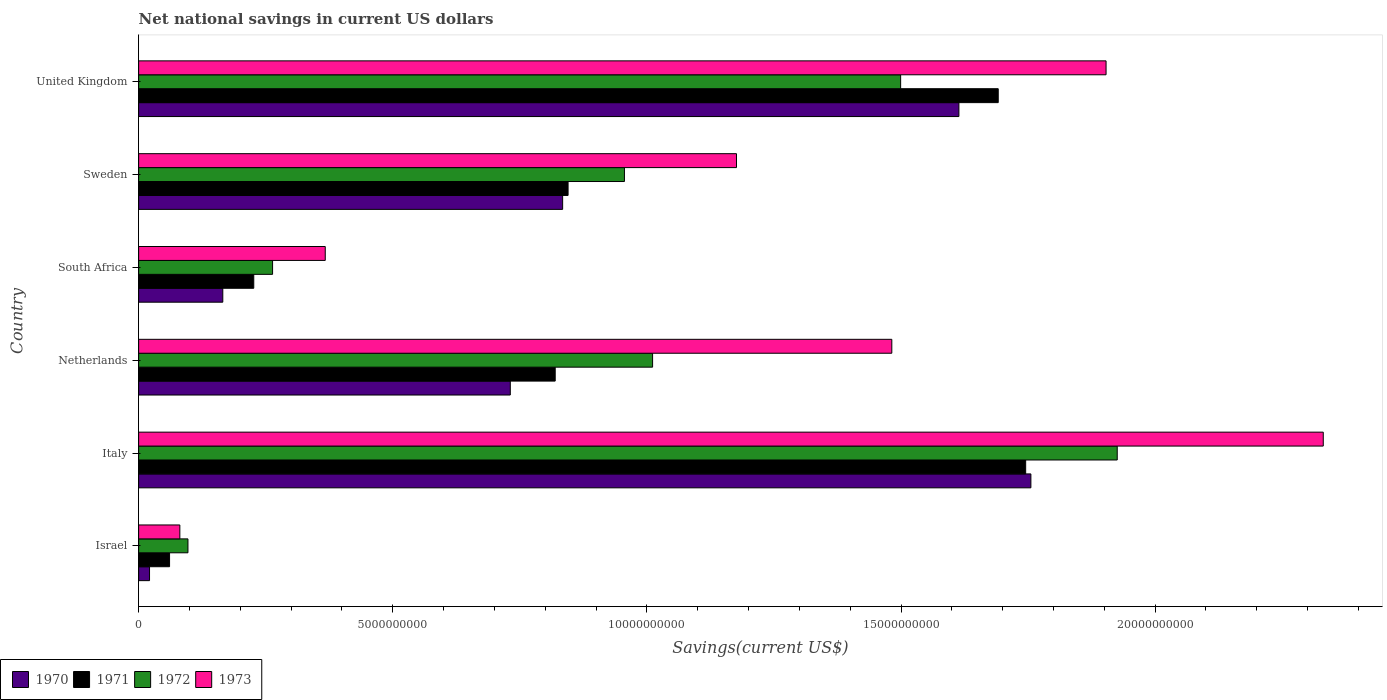How many different coloured bars are there?
Your response must be concise. 4. How many groups of bars are there?
Provide a succinct answer. 6. Are the number of bars per tick equal to the number of legend labels?
Ensure brevity in your answer.  Yes. Are the number of bars on each tick of the Y-axis equal?
Offer a very short reply. Yes. How many bars are there on the 5th tick from the top?
Offer a terse response. 4. How many bars are there on the 3rd tick from the bottom?
Ensure brevity in your answer.  4. What is the net national savings in 1971 in Israel?
Provide a succinct answer. 6.09e+08. Across all countries, what is the maximum net national savings in 1971?
Your response must be concise. 1.75e+1. Across all countries, what is the minimum net national savings in 1973?
Make the answer very short. 8.11e+08. What is the total net national savings in 1973 in the graph?
Provide a succinct answer. 7.34e+1. What is the difference between the net national savings in 1971 in Italy and that in Netherlands?
Your answer should be compact. 9.26e+09. What is the difference between the net national savings in 1973 in United Kingdom and the net national savings in 1970 in South Africa?
Your response must be concise. 1.74e+1. What is the average net national savings in 1973 per country?
Provide a short and direct response. 1.22e+1. What is the difference between the net national savings in 1971 and net national savings in 1972 in Sweden?
Your response must be concise. -1.11e+09. What is the ratio of the net national savings in 1970 in Italy to that in South Africa?
Your answer should be compact. 10.6. What is the difference between the highest and the second highest net national savings in 1973?
Ensure brevity in your answer.  4.27e+09. What is the difference between the highest and the lowest net national savings in 1970?
Keep it short and to the point. 1.73e+1. In how many countries, is the net national savings in 1973 greater than the average net national savings in 1973 taken over all countries?
Your answer should be compact. 3. Is the sum of the net national savings in 1973 in Netherlands and United Kingdom greater than the maximum net national savings in 1970 across all countries?
Provide a short and direct response. Yes. Is it the case that in every country, the sum of the net national savings in 1973 and net national savings in 1972 is greater than the sum of net national savings in 1971 and net national savings in 1970?
Provide a short and direct response. No. What does the 3rd bar from the bottom in Italy represents?
Offer a terse response. 1972. Is it the case that in every country, the sum of the net national savings in 1972 and net national savings in 1971 is greater than the net national savings in 1970?
Ensure brevity in your answer.  Yes. How many bars are there?
Your answer should be compact. 24. Are the values on the major ticks of X-axis written in scientific E-notation?
Make the answer very short. No. Does the graph contain grids?
Your answer should be compact. No. How many legend labels are there?
Ensure brevity in your answer.  4. How are the legend labels stacked?
Give a very brief answer. Horizontal. What is the title of the graph?
Offer a terse response. Net national savings in current US dollars. Does "1988" appear as one of the legend labels in the graph?
Provide a short and direct response. No. What is the label or title of the X-axis?
Your answer should be compact. Savings(current US$). What is the label or title of the Y-axis?
Ensure brevity in your answer.  Country. What is the Savings(current US$) of 1970 in Israel?
Provide a succinct answer. 2.15e+08. What is the Savings(current US$) in 1971 in Israel?
Provide a succinct answer. 6.09e+08. What is the Savings(current US$) of 1972 in Israel?
Provide a short and direct response. 9.71e+08. What is the Savings(current US$) of 1973 in Israel?
Your response must be concise. 8.11e+08. What is the Savings(current US$) of 1970 in Italy?
Ensure brevity in your answer.  1.76e+1. What is the Savings(current US$) in 1971 in Italy?
Your answer should be compact. 1.75e+1. What is the Savings(current US$) in 1972 in Italy?
Keep it short and to the point. 1.93e+1. What is the Savings(current US$) in 1973 in Italy?
Offer a very short reply. 2.33e+1. What is the Savings(current US$) of 1970 in Netherlands?
Offer a very short reply. 7.31e+09. What is the Savings(current US$) in 1971 in Netherlands?
Your answer should be very brief. 8.20e+09. What is the Savings(current US$) in 1972 in Netherlands?
Offer a terse response. 1.01e+1. What is the Savings(current US$) in 1973 in Netherlands?
Ensure brevity in your answer.  1.48e+1. What is the Savings(current US$) of 1970 in South Africa?
Provide a short and direct response. 1.66e+09. What is the Savings(current US$) in 1971 in South Africa?
Offer a very short reply. 2.27e+09. What is the Savings(current US$) in 1972 in South Africa?
Keep it short and to the point. 2.64e+09. What is the Savings(current US$) of 1973 in South Africa?
Give a very brief answer. 3.67e+09. What is the Savings(current US$) in 1970 in Sweden?
Offer a terse response. 8.34e+09. What is the Savings(current US$) in 1971 in Sweden?
Offer a very short reply. 8.45e+09. What is the Savings(current US$) of 1972 in Sweden?
Provide a succinct answer. 9.56e+09. What is the Savings(current US$) in 1973 in Sweden?
Make the answer very short. 1.18e+1. What is the Savings(current US$) of 1970 in United Kingdom?
Your answer should be compact. 1.61e+1. What is the Savings(current US$) of 1971 in United Kingdom?
Give a very brief answer. 1.69e+1. What is the Savings(current US$) in 1972 in United Kingdom?
Keep it short and to the point. 1.50e+1. What is the Savings(current US$) in 1973 in United Kingdom?
Offer a very short reply. 1.90e+1. Across all countries, what is the maximum Savings(current US$) in 1970?
Ensure brevity in your answer.  1.76e+1. Across all countries, what is the maximum Savings(current US$) in 1971?
Your response must be concise. 1.75e+1. Across all countries, what is the maximum Savings(current US$) of 1972?
Your answer should be compact. 1.93e+1. Across all countries, what is the maximum Savings(current US$) of 1973?
Offer a terse response. 2.33e+1. Across all countries, what is the minimum Savings(current US$) of 1970?
Provide a succinct answer. 2.15e+08. Across all countries, what is the minimum Savings(current US$) in 1971?
Make the answer very short. 6.09e+08. Across all countries, what is the minimum Savings(current US$) of 1972?
Your answer should be very brief. 9.71e+08. Across all countries, what is the minimum Savings(current US$) of 1973?
Offer a very short reply. 8.11e+08. What is the total Savings(current US$) in 1970 in the graph?
Offer a terse response. 5.12e+1. What is the total Savings(current US$) in 1971 in the graph?
Your answer should be compact. 5.39e+1. What is the total Savings(current US$) in 1972 in the graph?
Offer a very short reply. 5.75e+1. What is the total Savings(current US$) of 1973 in the graph?
Make the answer very short. 7.34e+1. What is the difference between the Savings(current US$) in 1970 in Israel and that in Italy?
Make the answer very short. -1.73e+1. What is the difference between the Savings(current US$) in 1971 in Israel and that in Italy?
Offer a terse response. -1.68e+1. What is the difference between the Savings(current US$) in 1972 in Israel and that in Italy?
Offer a terse response. -1.83e+1. What is the difference between the Savings(current US$) in 1973 in Israel and that in Italy?
Provide a short and direct response. -2.25e+1. What is the difference between the Savings(current US$) of 1970 in Israel and that in Netherlands?
Make the answer very short. -7.10e+09. What is the difference between the Savings(current US$) of 1971 in Israel and that in Netherlands?
Give a very brief answer. -7.59e+09. What is the difference between the Savings(current US$) of 1972 in Israel and that in Netherlands?
Offer a terse response. -9.14e+09. What is the difference between the Savings(current US$) of 1973 in Israel and that in Netherlands?
Ensure brevity in your answer.  -1.40e+1. What is the difference between the Savings(current US$) in 1970 in Israel and that in South Africa?
Your response must be concise. -1.44e+09. What is the difference between the Savings(current US$) of 1971 in Israel and that in South Africa?
Ensure brevity in your answer.  -1.66e+09. What is the difference between the Savings(current US$) in 1972 in Israel and that in South Africa?
Keep it short and to the point. -1.66e+09. What is the difference between the Savings(current US$) in 1973 in Israel and that in South Africa?
Offer a very short reply. -2.86e+09. What is the difference between the Savings(current US$) in 1970 in Israel and that in Sweden?
Provide a short and direct response. -8.13e+09. What is the difference between the Savings(current US$) in 1971 in Israel and that in Sweden?
Your answer should be very brief. -7.84e+09. What is the difference between the Savings(current US$) in 1972 in Israel and that in Sweden?
Give a very brief answer. -8.59e+09. What is the difference between the Savings(current US$) in 1973 in Israel and that in Sweden?
Offer a terse response. -1.10e+1. What is the difference between the Savings(current US$) in 1970 in Israel and that in United Kingdom?
Give a very brief answer. -1.59e+1. What is the difference between the Savings(current US$) in 1971 in Israel and that in United Kingdom?
Your answer should be very brief. -1.63e+1. What is the difference between the Savings(current US$) of 1972 in Israel and that in United Kingdom?
Offer a very short reply. -1.40e+1. What is the difference between the Savings(current US$) of 1973 in Israel and that in United Kingdom?
Provide a short and direct response. -1.82e+1. What is the difference between the Savings(current US$) in 1970 in Italy and that in Netherlands?
Keep it short and to the point. 1.02e+1. What is the difference between the Savings(current US$) of 1971 in Italy and that in Netherlands?
Offer a very short reply. 9.26e+09. What is the difference between the Savings(current US$) of 1972 in Italy and that in Netherlands?
Provide a short and direct response. 9.14e+09. What is the difference between the Savings(current US$) of 1973 in Italy and that in Netherlands?
Your answer should be very brief. 8.49e+09. What is the difference between the Savings(current US$) of 1970 in Italy and that in South Africa?
Your answer should be compact. 1.59e+1. What is the difference between the Savings(current US$) in 1971 in Italy and that in South Africa?
Make the answer very short. 1.52e+1. What is the difference between the Savings(current US$) in 1972 in Italy and that in South Africa?
Give a very brief answer. 1.66e+1. What is the difference between the Savings(current US$) of 1973 in Italy and that in South Africa?
Make the answer very short. 1.96e+1. What is the difference between the Savings(current US$) of 1970 in Italy and that in Sweden?
Your answer should be compact. 9.21e+09. What is the difference between the Savings(current US$) in 1971 in Italy and that in Sweden?
Give a very brief answer. 9.00e+09. What is the difference between the Savings(current US$) in 1972 in Italy and that in Sweden?
Give a very brief answer. 9.70e+09. What is the difference between the Savings(current US$) in 1973 in Italy and that in Sweden?
Offer a very short reply. 1.15e+1. What is the difference between the Savings(current US$) of 1970 in Italy and that in United Kingdom?
Ensure brevity in your answer.  1.42e+09. What is the difference between the Savings(current US$) in 1971 in Italy and that in United Kingdom?
Offer a terse response. 5.40e+08. What is the difference between the Savings(current US$) in 1972 in Italy and that in United Kingdom?
Offer a terse response. 4.26e+09. What is the difference between the Savings(current US$) in 1973 in Italy and that in United Kingdom?
Make the answer very short. 4.27e+09. What is the difference between the Savings(current US$) in 1970 in Netherlands and that in South Africa?
Your answer should be very brief. 5.66e+09. What is the difference between the Savings(current US$) of 1971 in Netherlands and that in South Africa?
Provide a succinct answer. 5.93e+09. What is the difference between the Savings(current US$) in 1972 in Netherlands and that in South Africa?
Offer a terse response. 7.48e+09. What is the difference between the Savings(current US$) of 1973 in Netherlands and that in South Africa?
Offer a very short reply. 1.11e+1. What is the difference between the Savings(current US$) in 1970 in Netherlands and that in Sweden?
Your answer should be compact. -1.03e+09. What is the difference between the Savings(current US$) in 1971 in Netherlands and that in Sweden?
Provide a short and direct response. -2.53e+08. What is the difference between the Savings(current US$) in 1972 in Netherlands and that in Sweden?
Your response must be concise. 5.54e+08. What is the difference between the Savings(current US$) in 1973 in Netherlands and that in Sweden?
Offer a terse response. 3.06e+09. What is the difference between the Savings(current US$) of 1970 in Netherlands and that in United Kingdom?
Your answer should be very brief. -8.83e+09. What is the difference between the Savings(current US$) in 1971 in Netherlands and that in United Kingdom?
Make the answer very short. -8.72e+09. What is the difference between the Savings(current US$) in 1972 in Netherlands and that in United Kingdom?
Your answer should be compact. -4.88e+09. What is the difference between the Savings(current US$) of 1973 in Netherlands and that in United Kingdom?
Keep it short and to the point. -4.22e+09. What is the difference between the Savings(current US$) of 1970 in South Africa and that in Sweden?
Provide a succinct answer. -6.69e+09. What is the difference between the Savings(current US$) of 1971 in South Africa and that in Sweden?
Offer a terse response. -6.18e+09. What is the difference between the Savings(current US$) in 1972 in South Africa and that in Sweden?
Keep it short and to the point. -6.92e+09. What is the difference between the Savings(current US$) in 1973 in South Africa and that in Sweden?
Ensure brevity in your answer.  -8.09e+09. What is the difference between the Savings(current US$) in 1970 in South Africa and that in United Kingdom?
Keep it short and to the point. -1.45e+1. What is the difference between the Savings(current US$) in 1971 in South Africa and that in United Kingdom?
Your answer should be compact. -1.46e+1. What is the difference between the Savings(current US$) of 1972 in South Africa and that in United Kingdom?
Ensure brevity in your answer.  -1.24e+1. What is the difference between the Savings(current US$) of 1973 in South Africa and that in United Kingdom?
Ensure brevity in your answer.  -1.54e+1. What is the difference between the Savings(current US$) in 1970 in Sweden and that in United Kingdom?
Provide a short and direct response. -7.80e+09. What is the difference between the Savings(current US$) in 1971 in Sweden and that in United Kingdom?
Keep it short and to the point. -8.46e+09. What is the difference between the Savings(current US$) of 1972 in Sweden and that in United Kingdom?
Ensure brevity in your answer.  -5.43e+09. What is the difference between the Savings(current US$) in 1973 in Sweden and that in United Kingdom?
Ensure brevity in your answer.  -7.27e+09. What is the difference between the Savings(current US$) in 1970 in Israel and the Savings(current US$) in 1971 in Italy?
Make the answer very short. -1.72e+1. What is the difference between the Savings(current US$) of 1970 in Israel and the Savings(current US$) of 1972 in Italy?
Offer a very short reply. -1.90e+1. What is the difference between the Savings(current US$) in 1970 in Israel and the Savings(current US$) in 1973 in Italy?
Your response must be concise. -2.31e+1. What is the difference between the Savings(current US$) in 1971 in Israel and the Savings(current US$) in 1972 in Italy?
Your answer should be very brief. -1.86e+1. What is the difference between the Savings(current US$) of 1971 in Israel and the Savings(current US$) of 1973 in Italy?
Ensure brevity in your answer.  -2.27e+1. What is the difference between the Savings(current US$) of 1972 in Israel and the Savings(current US$) of 1973 in Italy?
Make the answer very short. -2.23e+1. What is the difference between the Savings(current US$) in 1970 in Israel and the Savings(current US$) in 1971 in Netherlands?
Make the answer very short. -7.98e+09. What is the difference between the Savings(current US$) in 1970 in Israel and the Savings(current US$) in 1972 in Netherlands?
Provide a succinct answer. -9.90e+09. What is the difference between the Savings(current US$) in 1970 in Israel and the Savings(current US$) in 1973 in Netherlands?
Offer a terse response. -1.46e+1. What is the difference between the Savings(current US$) in 1971 in Israel and the Savings(current US$) in 1972 in Netherlands?
Your answer should be very brief. -9.50e+09. What is the difference between the Savings(current US$) in 1971 in Israel and the Savings(current US$) in 1973 in Netherlands?
Keep it short and to the point. -1.42e+1. What is the difference between the Savings(current US$) in 1972 in Israel and the Savings(current US$) in 1973 in Netherlands?
Your answer should be compact. -1.38e+1. What is the difference between the Savings(current US$) of 1970 in Israel and the Savings(current US$) of 1971 in South Africa?
Keep it short and to the point. -2.05e+09. What is the difference between the Savings(current US$) of 1970 in Israel and the Savings(current US$) of 1972 in South Africa?
Provide a short and direct response. -2.42e+09. What is the difference between the Savings(current US$) in 1970 in Israel and the Savings(current US$) in 1973 in South Africa?
Provide a short and direct response. -3.46e+09. What is the difference between the Savings(current US$) in 1971 in Israel and the Savings(current US$) in 1972 in South Africa?
Provide a succinct answer. -2.03e+09. What is the difference between the Savings(current US$) in 1971 in Israel and the Savings(current US$) in 1973 in South Africa?
Keep it short and to the point. -3.06e+09. What is the difference between the Savings(current US$) of 1972 in Israel and the Savings(current US$) of 1973 in South Africa?
Make the answer very short. -2.70e+09. What is the difference between the Savings(current US$) in 1970 in Israel and the Savings(current US$) in 1971 in Sweden?
Keep it short and to the point. -8.23e+09. What is the difference between the Savings(current US$) of 1970 in Israel and the Savings(current US$) of 1972 in Sweden?
Give a very brief answer. -9.34e+09. What is the difference between the Savings(current US$) of 1970 in Israel and the Savings(current US$) of 1973 in Sweden?
Keep it short and to the point. -1.15e+1. What is the difference between the Savings(current US$) of 1971 in Israel and the Savings(current US$) of 1972 in Sweden?
Give a very brief answer. -8.95e+09. What is the difference between the Savings(current US$) of 1971 in Israel and the Savings(current US$) of 1973 in Sweden?
Ensure brevity in your answer.  -1.12e+1. What is the difference between the Savings(current US$) of 1972 in Israel and the Savings(current US$) of 1973 in Sweden?
Your response must be concise. -1.08e+1. What is the difference between the Savings(current US$) of 1970 in Israel and the Savings(current US$) of 1971 in United Kingdom?
Provide a succinct answer. -1.67e+1. What is the difference between the Savings(current US$) in 1970 in Israel and the Savings(current US$) in 1972 in United Kingdom?
Keep it short and to the point. -1.48e+1. What is the difference between the Savings(current US$) in 1970 in Israel and the Savings(current US$) in 1973 in United Kingdom?
Offer a terse response. -1.88e+1. What is the difference between the Savings(current US$) in 1971 in Israel and the Savings(current US$) in 1972 in United Kingdom?
Keep it short and to the point. -1.44e+1. What is the difference between the Savings(current US$) in 1971 in Israel and the Savings(current US$) in 1973 in United Kingdom?
Offer a very short reply. -1.84e+1. What is the difference between the Savings(current US$) in 1972 in Israel and the Savings(current US$) in 1973 in United Kingdom?
Offer a very short reply. -1.81e+1. What is the difference between the Savings(current US$) of 1970 in Italy and the Savings(current US$) of 1971 in Netherlands?
Offer a terse response. 9.36e+09. What is the difference between the Savings(current US$) of 1970 in Italy and the Savings(current US$) of 1972 in Netherlands?
Offer a terse response. 7.44e+09. What is the difference between the Savings(current US$) in 1970 in Italy and the Savings(current US$) in 1973 in Netherlands?
Give a very brief answer. 2.74e+09. What is the difference between the Savings(current US$) of 1971 in Italy and the Savings(current US$) of 1972 in Netherlands?
Provide a succinct answer. 7.34e+09. What is the difference between the Savings(current US$) of 1971 in Italy and the Savings(current US$) of 1973 in Netherlands?
Your answer should be very brief. 2.63e+09. What is the difference between the Savings(current US$) of 1972 in Italy and the Savings(current US$) of 1973 in Netherlands?
Your response must be concise. 4.44e+09. What is the difference between the Savings(current US$) of 1970 in Italy and the Savings(current US$) of 1971 in South Africa?
Make the answer very short. 1.53e+1. What is the difference between the Savings(current US$) of 1970 in Italy and the Savings(current US$) of 1972 in South Africa?
Offer a very short reply. 1.49e+1. What is the difference between the Savings(current US$) in 1970 in Italy and the Savings(current US$) in 1973 in South Africa?
Your answer should be compact. 1.39e+1. What is the difference between the Savings(current US$) in 1971 in Italy and the Savings(current US$) in 1972 in South Africa?
Your response must be concise. 1.48e+1. What is the difference between the Savings(current US$) in 1971 in Italy and the Savings(current US$) in 1973 in South Africa?
Ensure brevity in your answer.  1.38e+1. What is the difference between the Savings(current US$) in 1972 in Italy and the Savings(current US$) in 1973 in South Africa?
Ensure brevity in your answer.  1.56e+1. What is the difference between the Savings(current US$) of 1970 in Italy and the Savings(current US$) of 1971 in Sweden?
Make the answer very short. 9.11e+09. What is the difference between the Savings(current US$) of 1970 in Italy and the Savings(current US$) of 1972 in Sweden?
Ensure brevity in your answer.  8.00e+09. What is the difference between the Savings(current US$) in 1970 in Italy and the Savings(current US$) in 1973 in Sweden?
Provide a short and direct response. 5.79e+09. What is the difference between the Savings(current US$) in 1971 in Italy and the Savings(current US$) in 1972 in Sweden?
Your response must be concise. 7.89e+09. What is the difference between the Savings(current US$) of 1971 in Italy and the Savings(current US$) of 1973 in Sweden?
Provide a succinct answer. 5.69e+09. What is the difference between the Savings(current US$) of 1972 in Italy and the Savings(current US$) of 1973 in Sweden?
Ensure brevity in your answer.  7.49e+09. What is the difference between the Savings(current US$) in 1970 in Italy and the Savings(current US$) in 1971 in United Kingdom?
Provide a short and direct response. 6.43e+08. What is the difference between the Savings(current US$) in 1970 in Italy and the Savings(current US$) in 1972 in United Kingdom?
Offer a very short reply. 2.56e+09. What is the difference between the Savings(current US$) of 1970 in Italy and the Savings(current US$) of 1973 in United Kingdom?
Give a very brief answer. -1.48e+09. What is the difference between the Savings(current US$) of 1971 in Italy and the Savings(current US$) of 1972 in United Kingdom?
Your answer should be very brief. 2.46e+09. What is the difference between the Savings(current US$) of 1971 in Italy and the Savings(current US$) of 1973 in United Kingdom?
Offer a terse response. -1.58e+09. What is the difference between the Savings(current US$) in 1972 in Italy and the Savings(current US$) in 1973 in United Kingdom?
Make the answer very short. 2.20e+08. What is the difference between the Savings(current US$) of 1970 in Netherlands and the Savings(current US$) of 1971 in South Africa?
Give a very brief answer. 5.05e+09. What is the difference between the Savings(current US$) in 1970 in Netherlands and the Savings(current US$) in 1972 in South Africa?
Offer a very short reply. 4.68e+09. What is the difference between the Savings(current US$) in 1970 in Netherlands and the Savings(current US$) in 1973 in South Africa?
Offer a very short reply. 3.64e+09. What is the difference between the Savings(current US$) of 1971 in Netherlands and the Savings(current US$) of 1972 in South Africa?
Offer a terse response. 5.56e+09. What is the difference between the Savings(current US$) in 1971 in Netherlands and the Savings(current US$) in 1973 in South Africa?
Offer a very short reply. 4.52e+09. What is the difference between the Savings(current US$) of 1972 in Netherlands and the Savings(current US$) of 1973 in South Africa?
Keep it short and to the point. 6.44e+09. What is the difference between the Savings(current US$) of 1970 in Netherlands and the Savings(current US$) of 1971 in Sweden?
Your response must be concise. -1.14e+09. What is the difference between the Savings(current US$) of 1970 in Netherlands and the Savings(current US$) of 1972 in Sweden?
Your answer should be very brief. -2.25e+09. What is the difference between the Savings(current US$) in 1970 in Netherlands and the Savings(current US$) in 1973 in Sweden?
Provide a succinct answer. -4.45e+09. What is the difference between the Savings(current US$) of 1971 in Netherlands and the Savings(current US$) of 1972 in Sweden?
Provide a succinct answer. -1.36e+09. What is the difference between the Savings(current US$) of 1971 in Netherlands and the Savings(current US$) of 1973 in Sweden?
Make the answer very short. -3.57e+09. What is the difference between the Savings(current US$) in 1972 in Netherlands and the Savings(current US$) in 1973 in Sweden?
Provide a succinct answer. -1.65e+09. What is the difference between the Savings(current US$) in 1970 in Netherlands and the Savings(current US$) in 1971 in United Kingdom?
Your answer should be compact. -9.60e+09. What is the difference between the Savings(current US$) of 1970 in Netherlands and the Savings(current US$) of 1972 in United Kingdom?
Give a very brief answer. -7.68e+09. What is the difference between the Savings(current US$) in 1970 in Netherlands and the Savings(current US$) in 1973 in United Kingdom?
Make the answer very short. -1.17e+1. What is the difference between the Savings(current US$) of 1971 in Netherlands and the Savings(current US$) of 1972 in United Kingdom?
Your answer should be compact. -6.80e+09. What is the difference between the Savings(current US$) of 1971 in Netherlands and the Savings(current US$) of 1973 in United Kingdom?
Offer a very short reply. -1.08e+1. What is the difference between the Savings(current US$) in 1972 in Netherlands and the Savings(current US$) in 1973 in United Kingdom?
Give a very brief answer. -8.92e+09. What is the difference between the Savings(current US$) in 1970 in South Africa and the Savings(current US$) in 1971 in Sweden?
Your answer should be compact. -6.79e+09. What is the difference between the Savings(current US$) in 1970 in South Africa and the Savings(current US$) in 1972 in Sweden?
Offer a very short reply. -7.90e+09. What is the difference between the Savings(current US$) in 1970 in South Africa and the Savings(current US$) in 1973 in Sweden?
Your answer should be compact. -1.01e+1. What is the difference between the Savings(current US$) of 1971 in South Africa and the Savings(current US$) of 1972 in Sweden?
Offer a terse response. -7.29e+09. What is the difference between the Savings(current US$) of 1971 in South Africa and the Savings(current US$) of 1973 in Sweden?
Provide a succinct answer. -9.50e+09. What is the difference between the Savings(current US$) in 1972 in South Africa and the Savings(current US$) in 1973 in Sweden?
Provide a short and direct response. -9.13e+09. What is the difference between the Savings(current US$) in 1970 in South Africa and the Savings(current US$) in 1971 in United Kingdom?
Make the answer very short. -1.53e+1. What is the difference between the Savings(current US$) of 1970 in South Africa and the Savings(current US$) of 1972 in United Kingdom?
Offer a terse response. -1.33e+1. What is the difference between the Savings(current US$) in 1970 in South Africa and the Savings(current US$) in 1973 in United Kingdom?
Offer a very short reply. -1.74e+1. What is the difference between the Savings(current US$) in 1971 in South Africa and the Savings(current US$) in 1972 in United Kingdom?
Your answer should be very brief. -1.27e+1. What is the difference between the Savings(current US$) in 1971 in South Africa and the Savings(current US$) in 1973 in United Kingdom?
Your response must be concise. -1.68e+1. What is the difference between the Savings(current US$) in 1972 in South Africa and the Savings(current US$) in 1973 in United Kingdom?
Offer a terse response. -1.64e+1. What is the difference between the Savings(current US$) of 1970 in Sweden and the Savings(current US$) of 1971 in United Kingdom?
Offer a terse response. -8.57e+09. What is the difference between the Savings(current US$) of 1970 in Sweden and the Savings(current US$) of 1972 in United Kingdom?
Make the answer very short. -6.65e+09. What is the difference between the Savings(current US$) in 1970 in Sweden and the Savings(current US$) in 1973 in United Kingdom?
Give a very brief answer. -1.07e+1. What is the difference between the Savings(current US$) of 1971 in Sweden and the Savings(current US$) of 1972 in United Kingdom?
Provide a short and direct response. -6.54e+09. What is the difference between the Savings(current US$) in 1971 in Sweden and the Savings(current US$) in 1973 in United Kingdom?
Give a very brief answer. -1.06e+1. What is the difference between the Savings(current US$) in 1972 in Sweden and the Savings(current US$) in 1973 in United Kingdom?
Give a very brief answer. -9.48e+09. What is the average Savings(current US$) in 1970 per country?
Keep it short and to the point. 8.54e+09. What is the average Savings(current US$) in 1971 per country?
Give a very brief answer. 8.98e+09. What is the average Savings(current US$) in 1972 per country?
Make the answer very short. 9.59e+09. What is the average Savings(current US$) of 1973 per country?
Give a very brief answer. 1.22e+1. What is the difference between the Savings(current US$) of 1970 and Savings(current US$) of 1971 in Israel?
Give a very brief answer. -3.94e+08. What is the difference between the Savings(current US$) in 1970 and Savings(current US$) in 1972 in Israel?
Keep it short and to the point. -7.56e+08. What is the difference between the Savings(current US$) of 1970 and Savings(current US$) of 1973 in Israel?
Your response must be concise. -5.96e+08. What is the difference between the Savings(current US$) in 1971 and Savings(current US$) in 1972 in Israel?
Your response must be concise. -3.62e+08. What is the difference between the Savings(current US$) of 1971 and Savings(current US$) of 1973 in Israel?
Your answer should be compact. -2.02e+08. What is the difference between the Savings(current US$) of 1972 and Savings(current US$) of 1973 in Israel?
Make the answer very short. 1.60e+08. What is the difference between the Savings(current US$) of 1970 and Savings(current US$) of 1971 in Italy?
Make the answer very short. 1.03e+08. What is the difference between the Savings(current US$) in 1970 and Savings(current US$) in 1972 in Italy?
Give a very brief answer. -1.70e+09. What is the difference between the Savings(current US$) of 1970 and Savings(current US$) of 1973 in Italy?
Ensure brevity in your answer.  -5.75e+09. What is the difference between the Savings(current US$) in 1971 and Savings(current US$) in 1972 in Italy?
Ensure brevity in your answer.  -1.80e+09. What is the difference between the Savings(current US$) of 1971 and Savings(current US$) of 1973 in Italy?
Offer a terse response. -5.86e+09. What is the difference between the Savings(current US$) in 1972 and Savings(current US$) in 1973 in Italy?
Provide a succinct answer. -4.05e+09. What is the difference between the Savings(current US$) of 1970 and Savings(current US$) of 1971 in Netherlands?
Ensure brevity in your answer.  -8.83e+08. What is the difference between the Savings(current US$) in 1970 and Savings(current US$) in 1972 in Netherlands?
Your answer should be very brief. -2.80e+09. What is the difference between the Savings(current US$) in 1970 and Savings(current US$) in 1973 in Netherlands?
Give a very brief answer. -7.51e+09. What is the difference between the Savings(current US$) of 1971 and Savings(current US$) of 1972 in Netherlands?
Ensure brevity in your answer.  -1.92e+09. What is the difference between the Savings(current US$) in 1971 and Savings(current US$) in 1973 in Netherlands?
Provide a short and direct response. -6.62e+09. What is the difference between the Savings(current US$) of 1972 and Savings(current US$) of 1973 in Netherlands?
Provide a succinct answer. -4.71e+09. What is the difference between the Savings(current US$) in 1970 and Savings(current US$) in 1971 in South Africa?
Give a very brief answer. -6.09e+08. What is the difference between the Savings(current US$) in 1970 and Savings(current US$) in 1972 in South Africa?
Provide a short and direct response. -9.79e+08. What is the difference between the Savings(current US$) in 1970 and Savings(current US$) in 1973 in South Africa?
Your answer should be compact. -2.02e+09. What is the difference between the Savings(current US$) in 1971 and Savings(current US$) in 1972 in South Africa?
Your answer should be very brief. -3.70e+08. What is the difference between the Savings(current US$) in 1971 and Savings(current US$) in 1973 in South Africa?
Offer a very short reply. -1.41e+09. What is the difference between the Savings(current US$) of 1972 and Savings(current US$) of 1973 in South Africa?
Your answer should be compact. -1.04e+09. What is the difference between the Savings(current US$) of 1970 and Savings(current US$) of 1971 in Sweden?
Your answer should be compact. -1.07e+08. What is the difference between the Savings(current US$) of 1970 and Savings(current US$) of 1972 in Sweden?
Give a very brief answer. -1.22e+09. What is the difference between the Savings(current US$) in 1970 and Savings(current US$) in 1973 in Sweden?
Your answer should be very brief. -3.42e+09. What is the difference between the Savings(current US$) of 1971 and Savings(current US$) of 1972 in Sweden?
Offer a terse response. -1.11e+09. What is the difference between the Savings(current US$) of 1971 and Savings(current US$) of 1973 in Sweden?
Your answer should be compact. -3.31e+09. What is the difference between the Savings(current US$) of 1972 and Savings(current US$) of 1973 in Sweden?
Your answer should be very brief. -2.20e+09. What is the difference between the Savings(current US$) of 1970 and Savings(current US$) of 1971 in United Kingdom?
Provide a succinct answer. -7.74e+08. What is the difference between the Savings(current US$) of 1970 and Savings(current US$) of 1972 in United Kingdom?
Your answer should be very brief. 1.15e+09. What is the difference between the Savings(current US$) of 1970 and Savings(current US$) of 1973 in United Kingdom?
Give a very brief answer. -2.90e+09. What is the difference between the Savings(current US$) in 1971 and Savings(current US$) in 1972 in United Kingdom?
Offer a very short reply. 1.92e+09. What is the difference between the Savings(current US$) in 1971 and Savings(current US$) in 1973 in United Kingdom?
Ensure brevity in your answer.  -2.12e+09. What is the difference between the Savings(current US$) of 1972 and Savings(current US$) of 1973 in United Kingdom?
Keep it short and to the point. -4.04e+09. What is the ratio of the Savings(current US$) in 1970 in Israel to that in Italy?
Offer a very short reply. 0.01. What is the ratio of the Savings(current US$) in 1971 in Israel to that in Italy?
Your answer should be compact. 0.03. What is the ratio of the Savings(current US$) in 1972 in Israel to that in Italy?
Offer a very short reply. 0.05. What is the ratio of the Savings(current US$) of 1973 in Israel to that in Italy?
Make the answer very short. 0.03. What is the ratio of the Savings(current US$) in 1970 in Israel to that in Netherlands?
Offer a terse response. 0.03. What is the ratio of the Savings(current US$) of 1971 in Israel to that in Netherlands?
Make the answer very short. 0.07. What is the ratio of the Savings(current US$) of 1972 in Israel to that in Netherlands?
Your response must be concise. 0.1. What is the ratio of the Savings(current US$) of 1973 in Israel to that in Netherlands?
Ensure brevity in your answer.  0.05. What is the ratio of the Savings(current US$) of 1970 in Israel to that in South Africa?
Ensure brevity in your answer.  0.13. What is the ratio of the Savings(current US$) of 1971 in Israel to that in South Africa?
Make the answer very short. 0.27. What is the ratio of the Savings(current US$) of 1972 in Israel to that in South Africa?
Provide a short and direct response. 0.37. What is the ratio of the Savings(current US$) of 1973 in Israel to that in South Africa?
Your answer should be very brief. 0.22. What is the ratio of the Savings(current US$) of 1970 in Israel to that in Sweden?
Keep it short and to the point. 0.03. What is the ratio of the Savings(current US$) in 1971 in Israel to that in Sweden?
Provide a succinct answer. 0.07. What is the ratio of the Savings(current US$) of 1972 in Israel to that in Sweden?
Give a very brief answer. 0.1. What is the ratio of the Savings(current US$) in 1973 in Israel to that in Sweden?
Your response must be concise. 0.07. What is the ratio of the Savings(current US$) in 1970 in Israel to that in United Kingdom?
Offer a very short reply. 0.01. What is the ratio of the Savings(current US$) of 1971 in Israel to that in United Kingdom?
Offer a very short reply. 0.04. What is the ratio of the Savings(current US$) of 1972 in Israel to that in United Kingdom?
Your answer should be very brief. 0.06. What is the ratio of the Savings(current US$) of 1973 in Israel to that in United Kingdom?
Provide a succinct answer. 0.04. What is the ratio of the Savings(current US$) of 1970 in Italy to that in Netherlands?
Make the answer very short. 2.4. What is the ratio of the Savings(current US$) in 1971 in Italy to that in Netherlands?
Offer a terse response. 2.13. What is the ratio of the Savings(current US$) in 1972 in Italy to that in Netherlands?
Offer a very short reply. 1.9. What is the ratio of the Savings(current US$) of 1973 in Italy to that in Netherlands?
Offer a terse response. 1.57. What is the ratio of the Savings(current US$) of 1970 in Italy to that in South Africa?
Provide a short and direct response. 10.6. What is the ratio of the Savings(current US$) in 1971 in Italy to that in South Africa?
Make the answer very short. 7.7. What is the ratio of the Savings(current US$) of 1972 in Italy to that in South Africa?
Your answer should be very brief. 7.31. What is the ratio of the Savings(current US$) of 1973 in Italy to that in South Africa?
Offer a terse response. 6.35. What is the ratio of the Savings(current US$) in 1970 in Italy to that in Sweden?
Make the answer very short. 2.1. What is the ratio of the Savings(current US$) in 1971 in Italy to that in Sweden?
Offer a very short reply. 2.07. What is the ratio of the Savings(current US$) of 1972 in Italy to that in Sweden?
Give a very brief answer. 2.01. What is the ratio of the Savings(current US$) in 1973 in Italy to that in Sweden?
Provide a succinct answer. 1.98. What is the ratio of the Savings(current US$) in 1970 in Italy to that in United Kingdom?
Your answer should be very brief. 1.09. What is the ratio of the Savings(current US$) in 1971 in Italy to that in United Kingdom?
Provide a short and direct response. 1.03. What is the ratio of the Savings(current US$) of 1972 in Italy to that in United Kingdom?
Your response must be concise. 1.28. What is the ratio of the Savings(current US$) of 1973 in Italy to that in United Kingdom?
Offer a very short reply. 1.22. What is the ratio of the Savings(current US$) in 1970 in Netherlands to that in South Africa?
Keep it short and to the point. 4.42. What is the ratio of the Savings(current US$) in 1971 in Netherlands to that in South Africa?
Your response must be concise. 3.62. What is the ratio of the Savings(current US$) in 1972 in Netherlands to that in South Africa?
Your answer should be very brief. 3.84. What is the ratio of the Savings(current US$) of 1973 in Netherlands to that in South Africa?
Offer a terse response. 4.04. What is the ratio of the Savings(current US$) in 1970 in Netherlands to that in Sweden?
Your response must be concise. 0.88. What is the ratio of the Savings(current US$) of 1972 in Netherlands to that in Sweden?
Offer a very short reply. 1.06. What is the ratio of the Savings(current US$) of 1973 in Netherlands to that in Sweden?
Your response must be concise. 1.26. What is the ratio of the Savings(current US$) of 1970 in Netherlands to that in United Kingdom?
Your response must be concise. 0.45. What is the ratio of the Savings(current US$) of 1971 in Netherlands to that in United Kingdom?
Your answer should be very brief. 0.48. What is the ratio of the Savings(current US$) in 1972 in Netherlands to that in United Kingdom?
Ensure brevity in your answer.  0.67. What is the ratio of the Savings(current US$) in 1973 in Netherlands to that in United Kingdom?
Your answer should be compact. 0.78. What is the ratio of the Savings(current US$) of 1970 in South Africa to that in Sweden?
Offer a terse response. 0.2. What is the ratio of the Savings(current US$) of 1971 in South Africa to that in Sweden?
Offer a very short reply. 0.27. What is the ratio of the Savings(current US$) in 1972 in South Africa to that in Sweden?
Offer a very short reply. 0.28. What is the ratio of the Savings(current US$) of 1973 in South Africa to that in Sweden?
Ensure brevity in your answer.  0.31. What is the ratio of the Savings(current US$) in 1970 in South Africa to that in United Kingdom?
Offer a terse response. 0.1. What is the ratio of the Savings(current US$) of 1971 in South Africa to that in United Kingdom?
Make the answer very short. 0.13. What is the ratio of the Savings(current US$) of 1972 in South Africa to that in United Kingdom?
Provide a short and direct response. 0.18. What is the ratio of the Savings(current US$) of 1973 in South Africa to that in United Kingdom?
Make the answer very short. 0.19. What is the ratio of the Savings(current US$) of 1970 in Sweden to that in United Kingdom?
Provide a short and direct response. 0.52. What is the ratio of the Savings(current US$) in 1971 in Sweden to that in United Kingdom?
Keep it short and to the point. 0.5. What is the ratio of the Savings(current US$) of 1972 in Sweden to that in United Kingdom?
Give a very brief answer. 0.64. What is the ratio of the Savings(current US$) in 1973 in Sweden to that in United Kingdom?
Keep it short and to the point. 0.62. What is the difference between the highest and the second highest Savings(current US$) in 1970?
Your answer should be compact. 1.42e+09. What is the difference between the highest and the second highest Savings(current US$) of 1971?
Offer a very short reply. 5.40e+08. What is the difference between the highest and the second highest Savings(current US$) of 1972?
Ensure brevity in your answer.  4.26e+09. What is the difference between the highest and the second highest Savings(current US$) of 1973?
Provide a succinct answer. 4.27e+09. What is the difference between the highest and the lowest Savings(current US$) in 1970?
Offer a terse response. 1.73e+1. What is the difference between the highest and the lowest Savings(current US$) of 1971?
Ensure brevity in your answer.  1.68e+1. What is the difference between the highest and the lowest Savings(current US$) in 1972?
Provide a short and direct response. 1.83e+1. What is the difference between the highest and the lowest Savings(current US$) of 1973?
Offer a very short reply. 2.25e+1. 